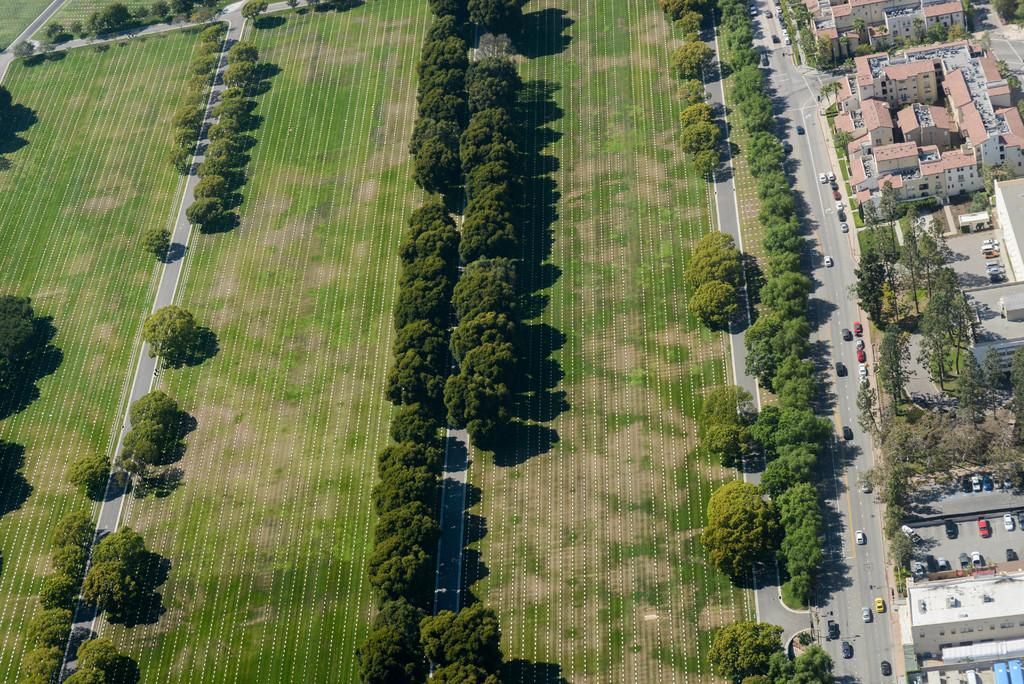What type of view is provided in the image? The image is a top view. What can be seen on the left side of the image? There are roads, grass, and trees on the left side of the image. What is present on the right side of the image? There are vehicles on the road, buildings, roofs, and trees on the right side of the image. What type of stew is being served in the image? There is no stew present in the image; it features a top view of roads, grass, trees, vehicles, buildings, roofs, and more. How many dolls can be seen interacting with the trees on the right side of the image? There are no dolls present in the image; it features a top view of roads, grass, trees, vehicles, buildings, roofs, and more. 